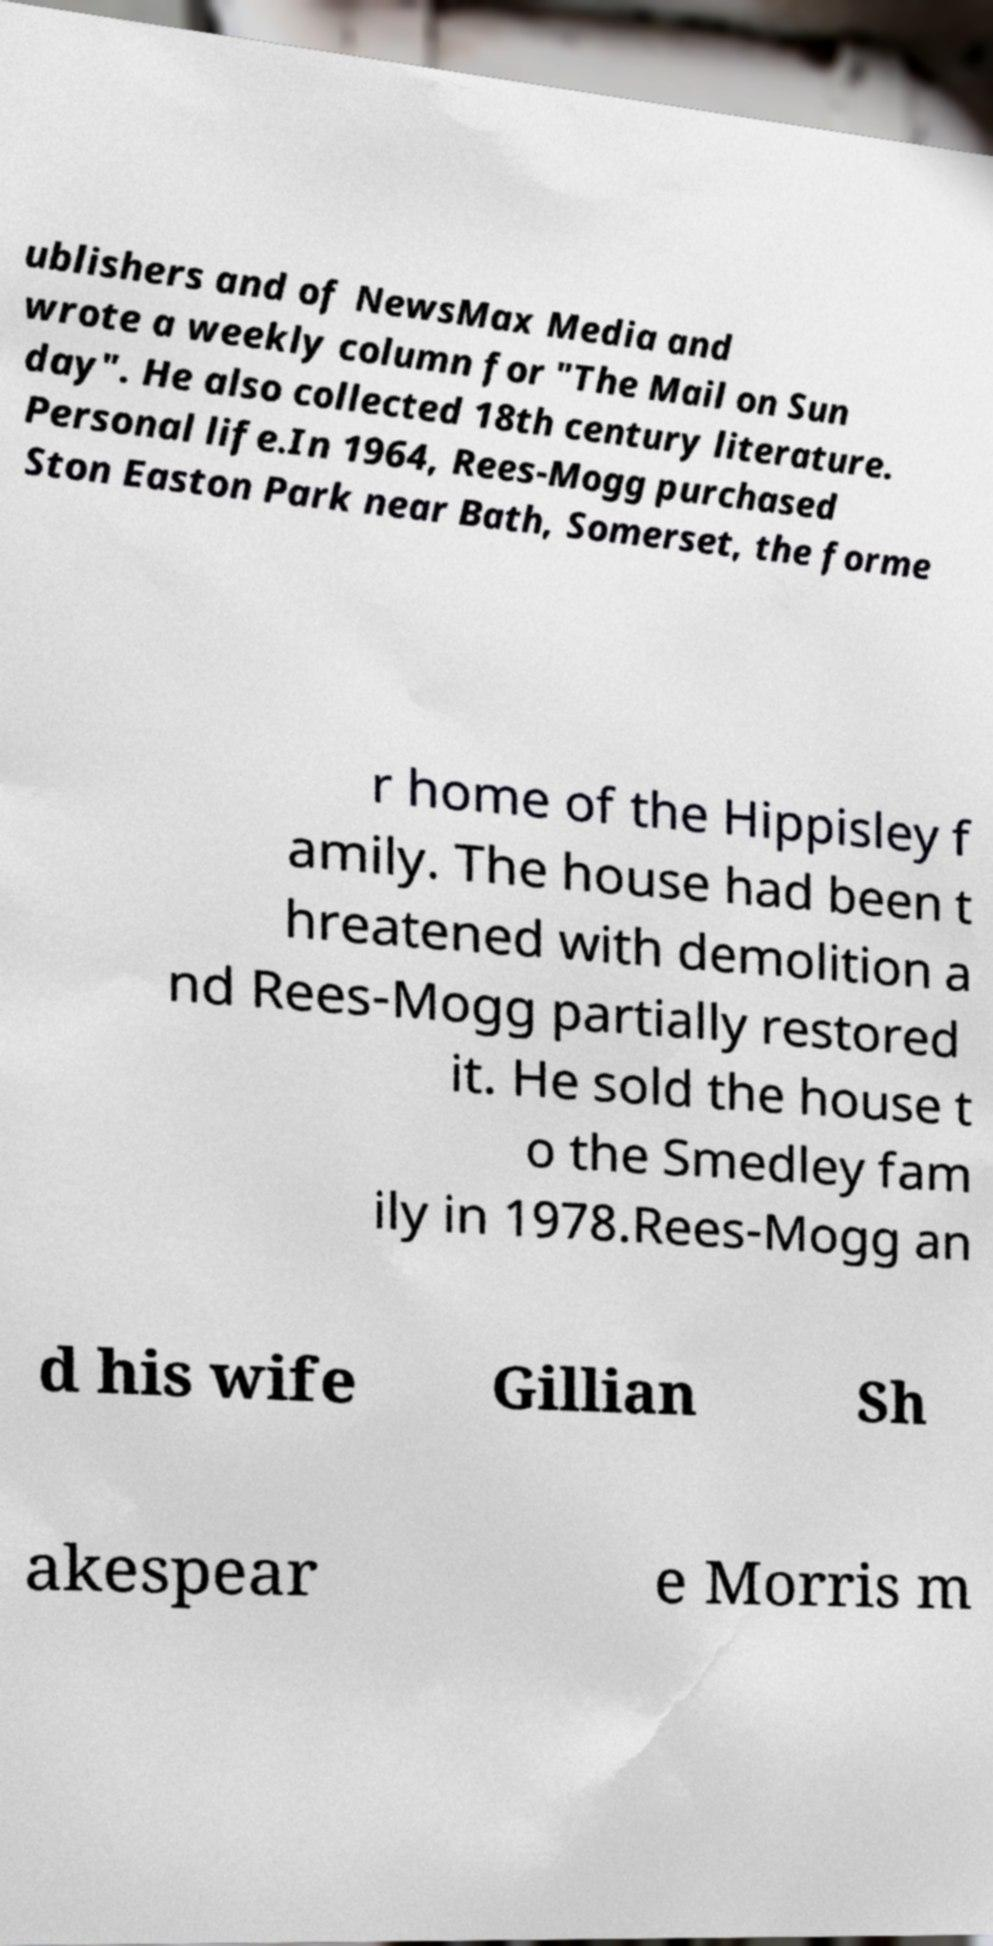For documentation purposes, I need the text within this image transcribed. Could you provide that? ublishers and of NewsMax Media and wrote a weekly column for "The Mail on Sun day". He also collected 18th century literature. Personal life.In 1964, Rees-Mogg purchased Ston Easton Park near Bath, Somerset, the forme r home of the Hippisley f amily. The house had been t hreatened with demolition a nd Rees-Mogg partially restored it. He sold the house t o the Smedley fam ily in 1978.Rees-Mogg an d his wife Gillian Sh akespear e Morris m 